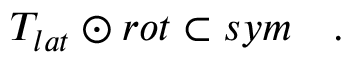<formula> <loc_0><loc_0><loc_500><loc_500>T _ { l a t } \odot r o t \subset s y m \quad .</formula> 